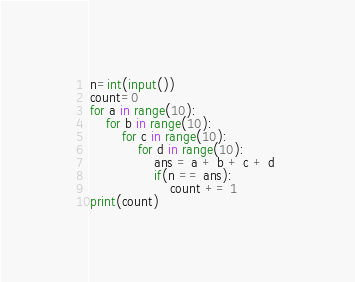Convert code to text. <code><loc_0><loc_0><loc_500><loc_500><_Python_>n=int(input())
count=0
for a in range(10):
	for b in range(10):
		for c in range(10):
			for d in range(10):
				ans = a + b + c + d 
				if(n == ans):
					count += 1 
print(count)
</code> 